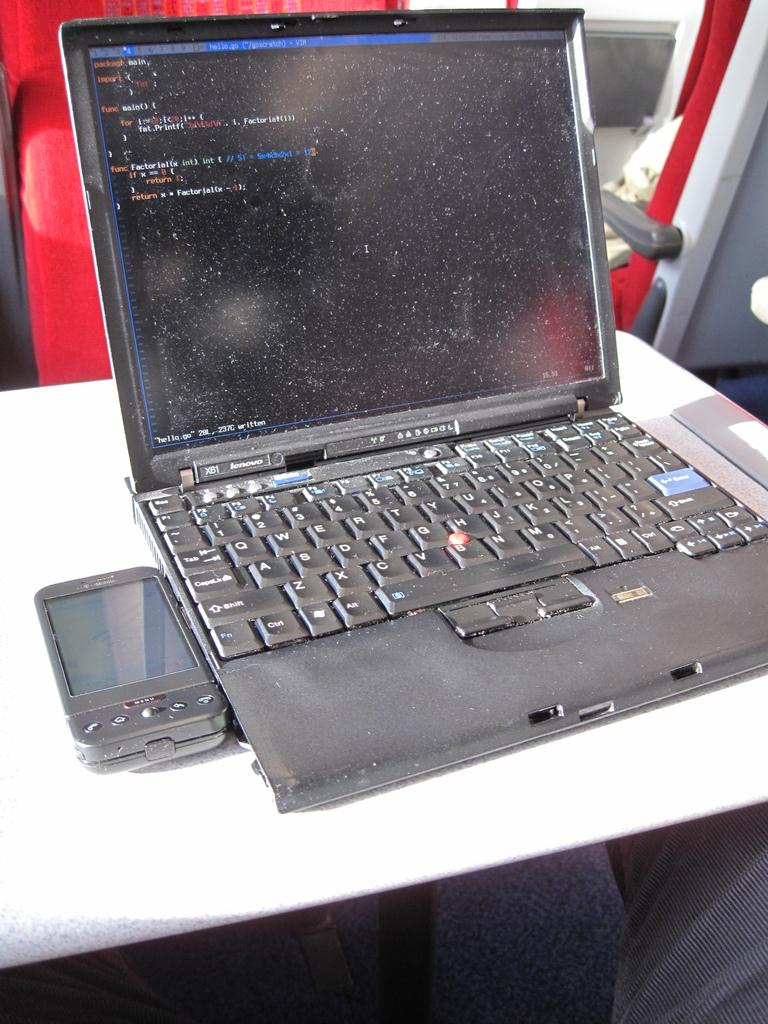<image>
Render a clear and concise summary of the photo. A lenovo laptop displaying a screen used to input code 